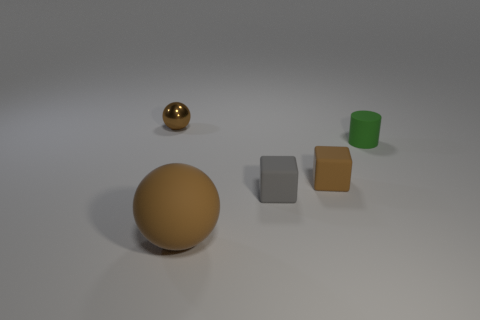What number of gray rubber cubes are in front of the sphere that is in front of the tiny brown object that is on the left side of the matte ball?
Your answer should be very brief. 0. How many blue things are either cylinders or tiny spheres?
Make the answer very short. 0. There is a thing behind the tiny cylinder; what is its shape?
Ensure brevity in your answer.  Sphere. There is a ball that is the same size as the green matte cylinder; what color is it?
Your response must be concise. Brown. There is a big brown thing; is its shape the same as the brown thing that is left of the big rubber sphere?
Ensure brevity in your answer.  Yes. There is a brown sphere behind the brown matte object in front of the block that is to the right of the gray matte thing; what is its material?
Your answer should be compact. Metal. What number of tiny objects are green things or balls?
Your response must be concise. 2. What number of other objects are the same size as the brown matte sphere?
Give a very brief answer. 0. There is a small brown object that is right of the gray thing; is it the same shape as the green rubber object?
Provide a short and direct response. No. There is another small object that is the same shape as the tiny gray object; what color is it?
Make the answer very short. Brown. 